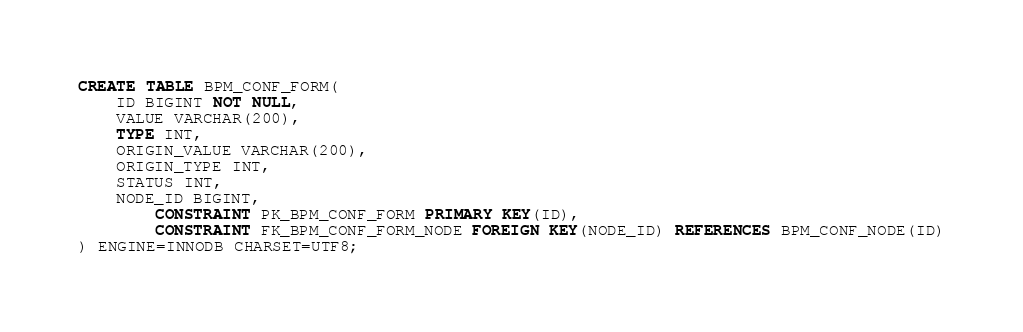<code> <loc_0><loc_0><loc_500><loc_500><_SQL_>
CREATE TABLE BPM_CONF_FORM(
	ID BIGINT NOT NULL,
	VALUE VARCHAR(200),
	TYPE INT,
	ORIGIN_VALUE VARCHAR(200),
	ORIGIN_TYPE INT,
	STATUS INT,
	NODE_ID BIGINT,
        CONSTRAINT PK_BPM_CONF_FORM PRIMARY KEY(ID),
        CONSTRAINT FK_BPM_CONF_FORM_NODE FOREIGN KEY(NODE_ID) REFERENCES BPM_CONF_NODE(ID)
) ENGINE=INNODB CHARSET=UTF8;










</code> 